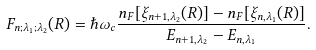Convert formula to latex. <formula><loc_0><loc_0><loc_500><loc_500>F _ { n ; \lambda _ { 1 } ; \lambda _ { 2 } } ( R ) = \hbar { \omega } _ { c } \frac { n _ { F } [ \xi _ { n + 1 , \lambda _ { 2 } } ( R ) ] - n _ { F } [ \xi _ { n , \lambda _ { 1 } } ( R ) ] } { E _ { n + 1 , \lambda _ { 2 } } - E _ { n , \lambda _ { 1 } } } .</formula> 